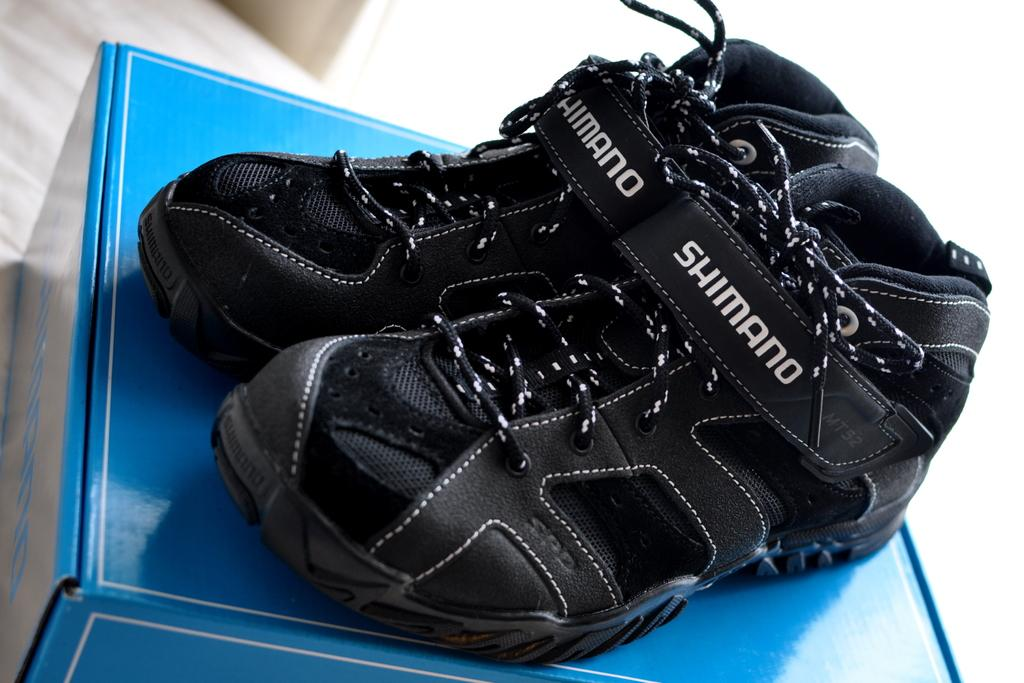What is the color of the cardboard box in the image? The cardboard box in the image is blue. What is placed on top of the cardboard box? There are black shoes on the box. What type of animals can be seen at the zoo in the image? A: There is no zoo or animals present in the image; it only features a blue color cardboard box with black shoes on top. 